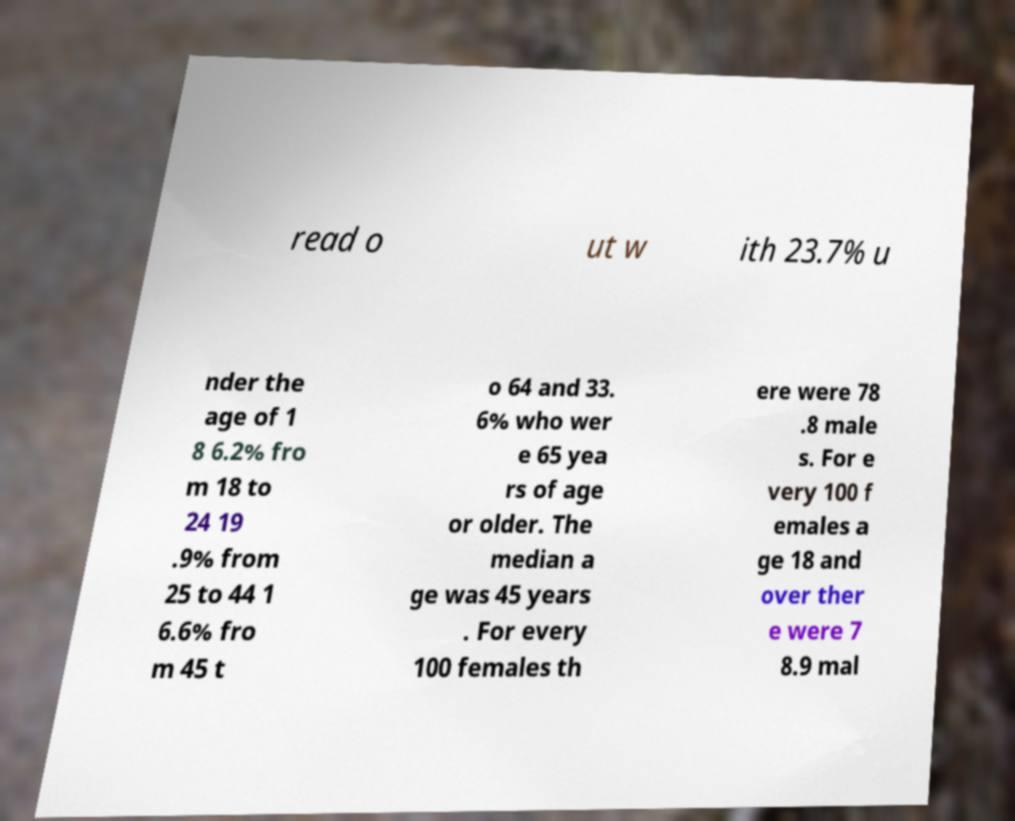Please read and relay the text visible in this image. What does it say? read o ut w ith 23.7% u nder the age of 1 8 6.2% fro m 18 to 24 19 .9% from 25 to 44 1 6.6% fro m 45 t o 64 and 33. 6% who wer e 65 yea rs of age or older. The median a ge was 45 years . For every 100 females th ere were 78 .8 male s. For e very 100 f emales a ge 18 and over ther e were 7 8.9 mal 